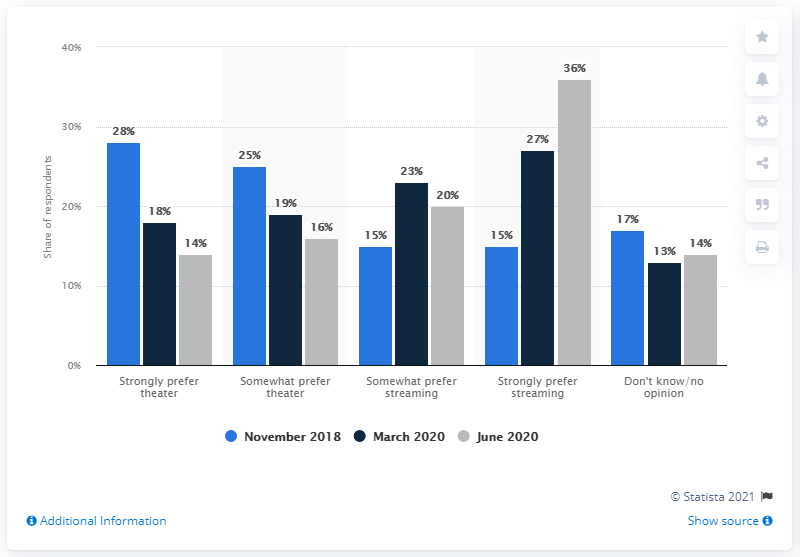Mention a couple of crucial points in this snapshot. The value of the longest bar is 36. In terms of length, the longest bar and the shortest bar differ by 23... According to a study conducted in June 2020, a significant percentage of adults, 36%, stated that they would much rather stream a film at home than visit a cinema. According to a survey, 14% of adults expressed a strong preference for watching a movie for the first time in a theater. 